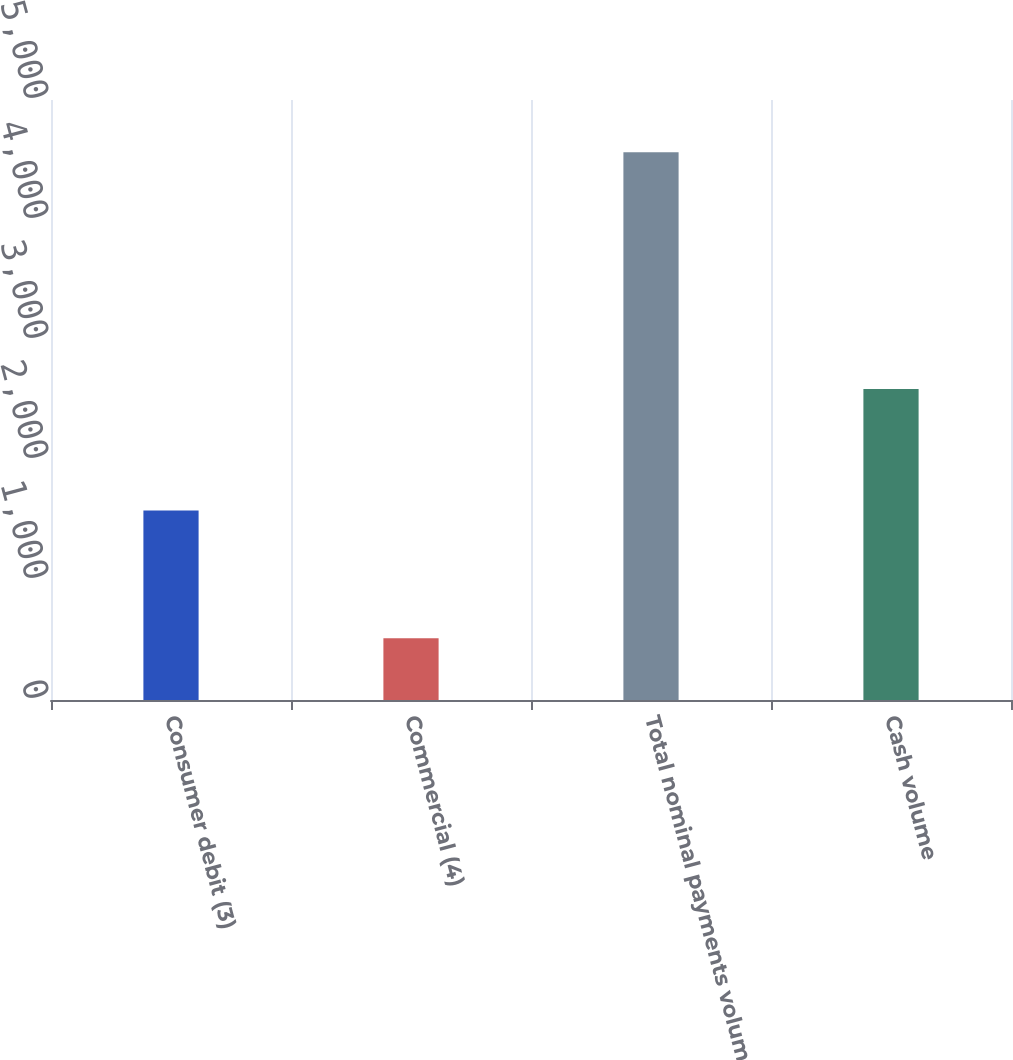Convert chart to OTSL. <chart><loc_0><loc_0><loc_500><loc_500><bar_chart><fcel>Consumer debit (3)<fcel>Commercial (4)<fcel>Total nominal payments volume<fcel>Cash volume<nl><fcel>1580<fcel>514<fcel>4565<fcel>2591<nl></chart> 